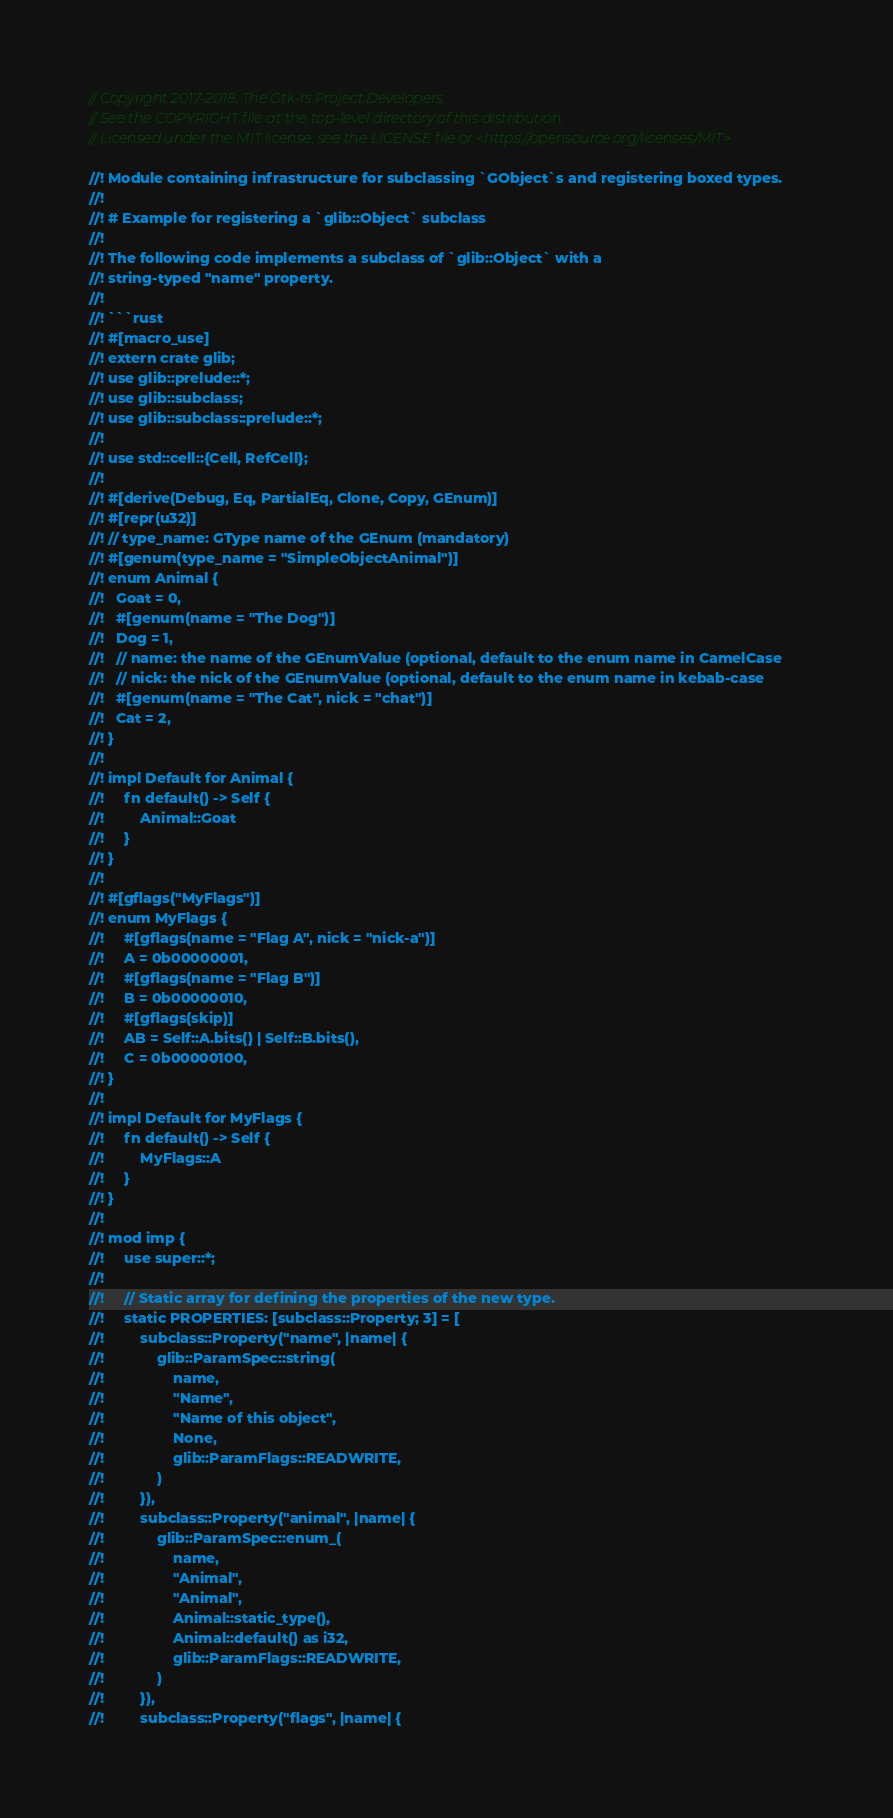<code> <loc_0><loc_0><loc_500><loc_500><_Rust_>// Copyright 2017-2018, The Gtk-rs Project Developers.
// See the COPYRIGHT file at the top-level directory of this distribution.
// Licensed under the MIT license, see the LICENSE file or <https://opensource.org/licenses/MIT>

//! Module containing infrastructure for subclassing `GObject`s and registering boxed types.
//!
//! # Example for registering a `glib::Object` subclass
//!
//! The following code implements a subclass of `glib::Object` with a
//! string-typed "name" property.
//!
//! ```rust
//! #[macro_use]
//! extern crate glib;
//! use glib::prelude::*;
//! use glib::subclass;
//! use glib::subclass::prelude::*;
//!
//! use std::cell::{Cell, RefCell};
//!
//! #[derive(Debug, Eq, PartialEq, Clone, Copy, GEnum)]
//! #[repr(u32)]
//! // type_name: GType name of the GEnum (mandatory)
//! #[genum(type_name = "SimpleObjectAnimal")]
//! enum Animal {
//!   Goat = 0,
//!   #[genum(name = "The Dog")]
//!   Dog = 1,
//!   // name: the name of the GEnumValue (optional, default to the enum name in CamelCase
//!   // nick: the nick of the GEnumValue (optional, default to the enum name in kebab-case
//!   #[genum(name = "The Cat", nick = "chat")]
//!   Cat = 2,
//! }
//!
//! impl Default for Animal {
//!     fn default() -> Self {
//!         Animal::Goat
//!     }
//! }
//!
//! #[gflags("MyFlags")]
//! enum MyFlags {
//!     #[gflags(name = "Flag A", nick = "nick-a")]
//!     A = 0b00000001,
//!     #[gflags(name = "Flag B")]
//!     B = 0b00000010,
//!     #[gflags(skip)]
//!     AB = Self::A.bits() | Self::B.bits(),
//!     C = 0b00000100,
//! }
//!
//! impl Default for MyFlags {
//!     fn default() -> Self {
//!         MyFlags::A
//!     }
//! }
//!
//! mod imp {
//!     use super::*;
//!
//!     // Static array for defining the properties of the new type.
//!     static PROPERTIES: [subclass::Property; 3] = [
//!         subclass::Property("name", |name| {
//!             glib::ParamSpec::string(
//!                 name,
//!                 "Name",
//!                 "Name of this object",
//!                 None,
//!                 glib::ParamFlags::READWRITE,
//!             )
//!         }),
//!         subclass::Property("animal", |name| {
//!             glib::ParamSpec::enum_(
//!                 name,
//!                 "Animal",
//!                 "Animal",
//!                 Animal::static_type(),
//!                 Animal::default() as i32,
//!                 glib::ParamFlags::READWRITE,
//!             )
//!         }),
//!         subclass::Property("flags", |name| {</code> 